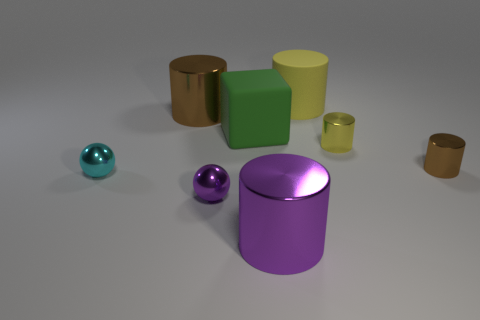Subtract all tiny cylinders. How many cylinders are left? 3 Subtract all brown cylinders. How many cylinders are left? 3 Add 1 purple cylinders. How many objects exist? 9 Subtract all red cylinders. Subtract all yellow spheres. How many cylinders are left? 5 Subtract all cylinders. How many objects are left? 3 Subtract all matte cylinders. Subtract all purple metallic balls. How many objects are left? 6 Add 4 brown shiny cylinders. How many brown shiny cylinders are left? 6 Add 3 large cylinders. How many large cylinders exist? 6 Subtract 0 blue cubes. How many objects are left? 8 